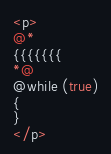Convert code to text. <code><loc_0><loc_0><loc_500><loc_500><_C#_><p>
@*
{{{{{{{
*@
@while (true)
{
}
</p>
</code> 